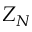Convert formula to latex. <formula><loc_0><loc_0><loc_500><loc_500>Z _ { N }</formula> 